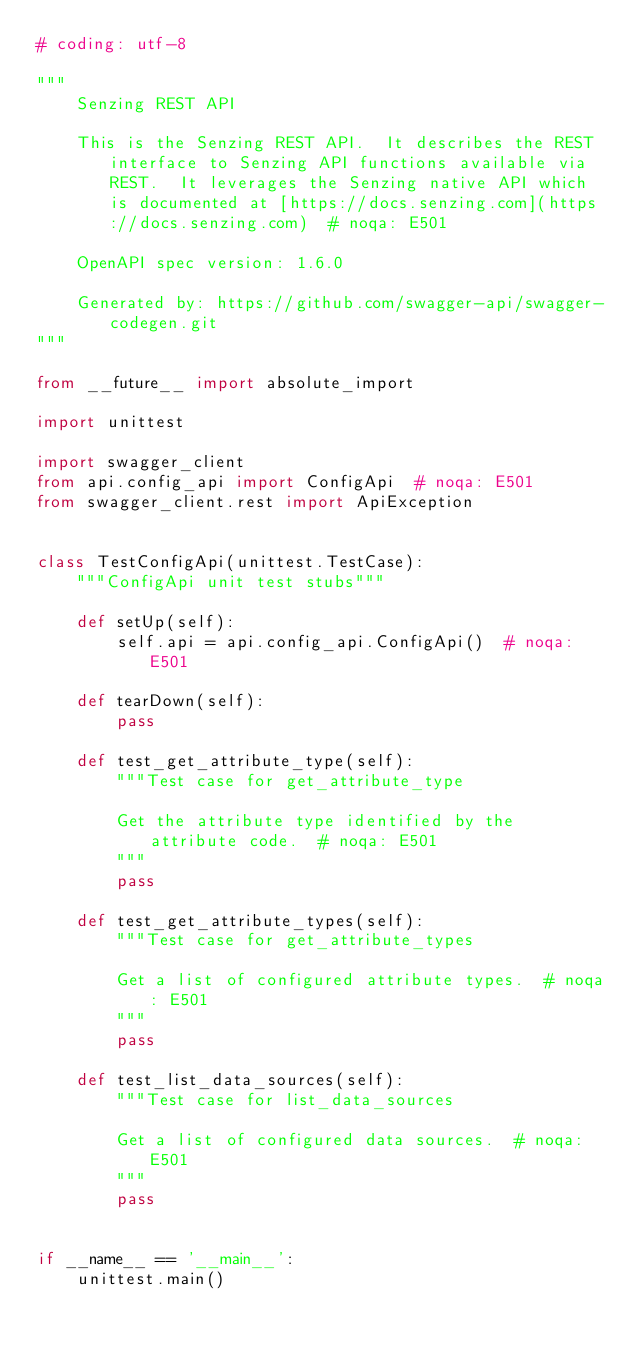Convert code to text. <code><loc_0><loc_0><loc_500><loc_500><_Python_># coding: utf-8

"""
    Senzing REST API

    This is the Senzing REST API.  It describes the REST interface to Senzing API functions available via REST.  It leverages the Senzing native API which is documented at [https://docs.senzing.com](https://docs.senzing.com)  # noqa: E501

    OpenAPI spec version: 1.6.0
    
    Generated by: https://github.com/swagger-api/swagger-codegen.git
"""

from __future__ import absolute_import

import unittest

import swagger_client
from api.config_api import ConfigApi  # noqa: E501
from swagger_client.rest import ApiException


class TestConfigApi(unittest.TestCase):
    """ConfigApi unit test stubs"""

    def setUp(self):
        self.api = api.config_api.ConfigApi()  # noqa: E501

    def tearDown(self):
        pass

    def test_get_attribute_type(self):
        """Test case for get_attribute_type

        Get the attribute type identified by the attribute code.  # noqa: E501
        """
        pass

    def test_get_attribute_types(self):
        """Test case for get_attribute_types

        Get a list of configured attribute types.  # noqa: E501
        """
        pass

    def test_list_data_sources(self):
        """Test case for list_data_sources

        Get a list of configured data sources.  # noqa: E501
        """
        pass


if __name__ == '__main__':
    unittest.main()
</code> 